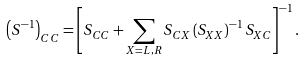Convert formula to latex. <formula><loc_0><loc_0><loc_500><loc_500>\left ( S ^ { - 1 } \right ) _ { C C } = \left [ S _ { C C } + \sum _ { X = L , R } S _ { C X } \left ( S _ { X X } \right ) ^ { - 1 } S _ { X C } \right ] ^ { - 1 } .</formula> 